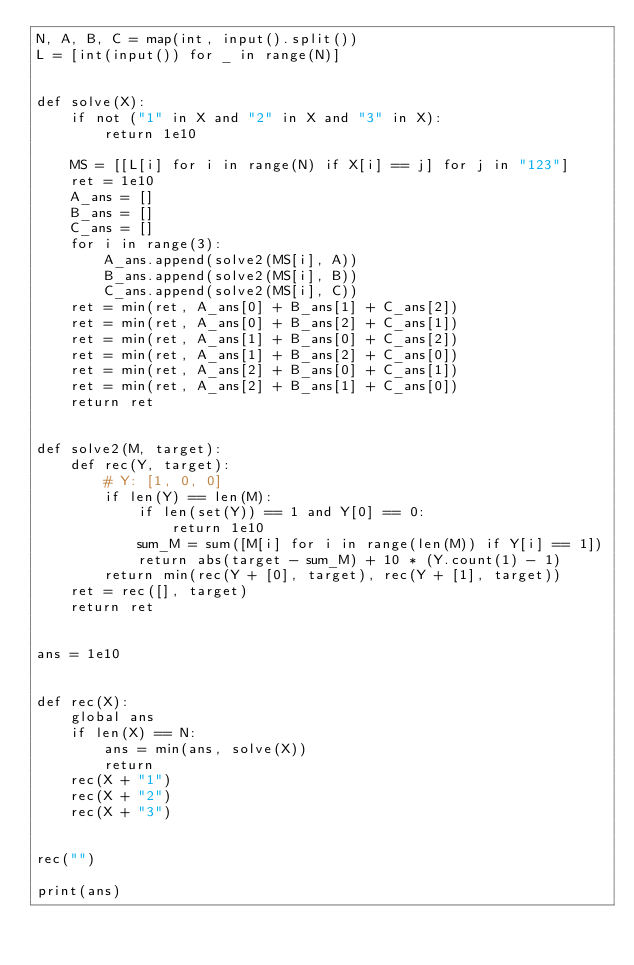Convert code to text. <code><loc_0><loc_0><loc_500><loc_500><_Python_>N, A, B, C = map(int, input().split())
L = [int(input()) for _ in range(N)]


def solve(X):
    if not ("1" in X and "2" in X and "3" in X):
        return 1e10

    MS = [[L[i] for i in range(N) if X[i] == j] for j in "123"]
    ret = 1e10
    A_ans = []
    B_ans = []
    C_ans = []
    for i in range(3):
        A_ans.append(solve2(MS[i], A))
        B_ans.append(solve2(MS[i], B))
        C_ans.append(solve2(MS[i], C))
    ret = min(ret, A_ans[0] + B_ans[1] + C_ans[2])
    ret = min(ret, A_ans[0] + B_ans[2] + C_ans[1])
    ret = min(ret, A_ans[1] + B_ans[0] + C_ans[2])
    ret = min(ret, A_ans[1] + B_ans[2] + C_ans[0])
    ret = min(ret, A_ans[2] + B_ans[0] + C_ans[1])
    ret = min(ret, A_ans[2] + B_ans[1] + C_ans[0])
    return ret


def solve2(M, target):
    def rec(Y, target):
        # Y: [1, 0, 0]
        if len(Y) == len(M):
            if len(set(Y)) == 1 and Y[0] == 0:
                return 1e10
            sum_M = sum([M[i] for i in range(len(M)) if Y[i] == 1])
            return abs(target - sum_M) + 10 * (Y.count(1) - 1)
        return min(rec(Y + [0], target), rec(Y + [1], target))
    ret = rec([], target)
    return ret


ans = 1e10


def rec(X):
    global ans
    if len(X) == N:
        ans = min(ans, solve(X))
        return
    rec(X + "1")
    rec(X + "2")
    rec(X + "3")


rec("")

print(ans)
</code> 